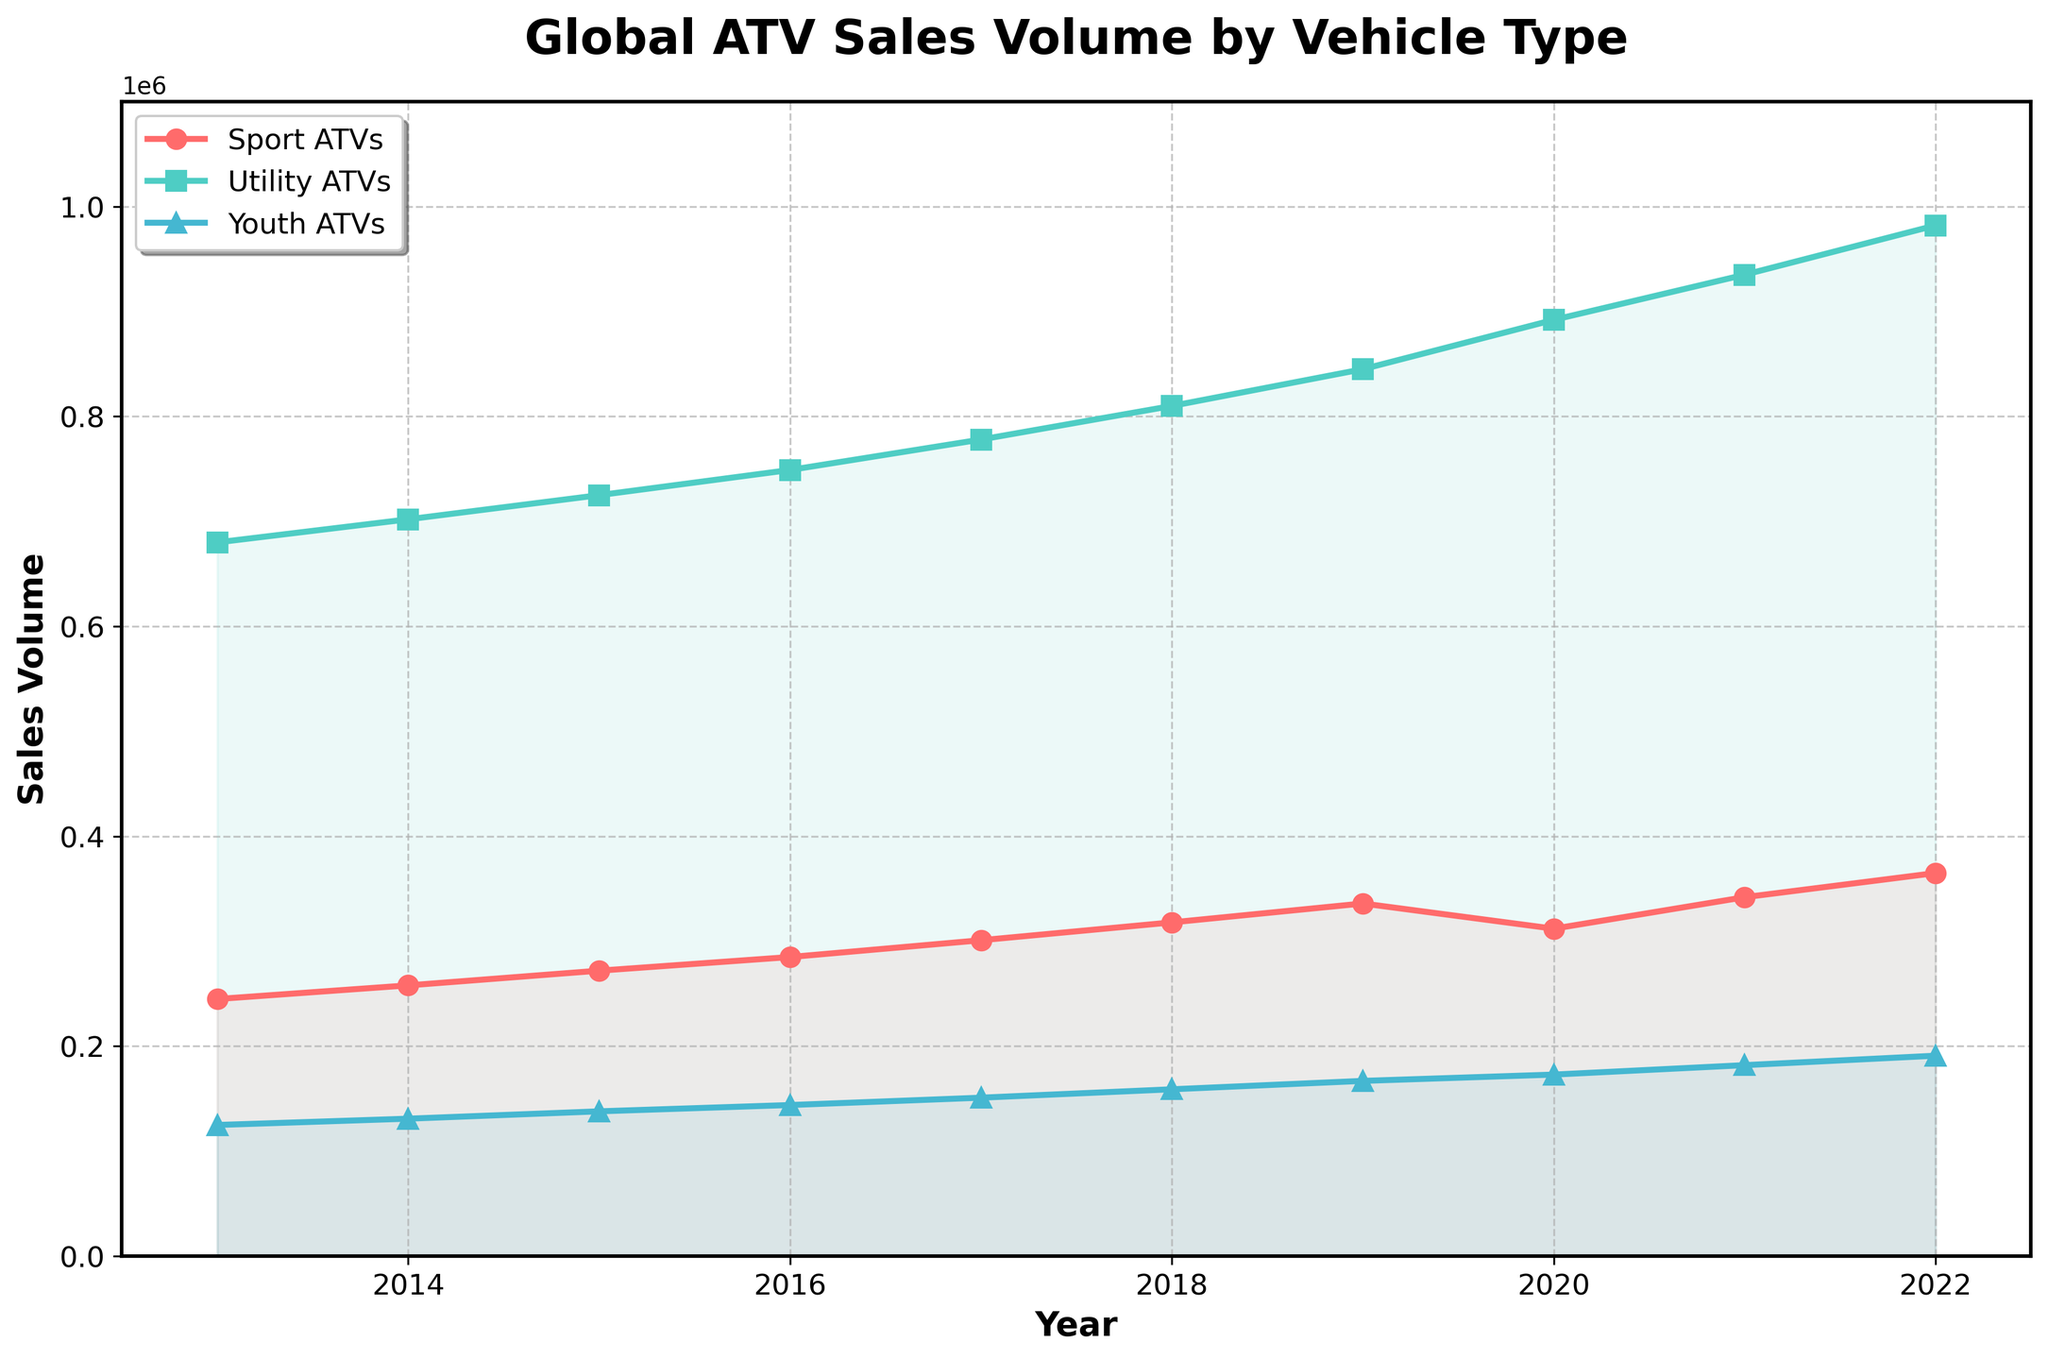What was the overall trend in Youth ATV sales from 2013 to 2022? From the plot, observe that the line representing Youth ATVs shows a consistent upward trend from 125,000 in 2013 to 191,000 in 2022. This trend indicates a steady increase in sales over the decade.
Answer: Steady increase Which year experienced a decline in Sport ATV sales? Locate the line for Sport ATVs and note that from 2019 to 2020, the number of sales dropped from 336,000 to 312,000.
Answer: 2020 What is the total sales volume for Utility ATVs in 2020 and 2021 combined? Identify the Utility ATVs sales volume for each of those years: 892,000 in 2020 and 935,000 in 2021. Add them together: 892,000 + 935,000 = 1,827,000.
Answer: 1,827,000 Compare the sales volume changes between Sport ATVs and Utility ATVs from 2021 to 2022. Which type had a greater increase? Sport ATVs increased from 342,000 to 365,000 (an increase of 23,000), and Utility ATVs increased from 935,000 to 982,000 (an increase of 47,000). Utility ATVs had a greater increase.
Answer: Utility ATVs What was the average sales volume for Sport ATVs over the last decade? Sum the Sport ATVs sales from 2013 to 2022 and divide by the number of years: (245,000 + 258,000 + 272,000 + 285,000 + 301,000 + 318,000 + 336,000 + 312,000 + 342,000 + 365,000) / 10 = 3,034,000 / 10.
Answer: 303,400 During which years did Utility ATVs consistently show an increasing trend? Observe the Utility ATVs line; from 2013 to 2022, the sales volume shows a consistent increase every year without any interruptions.
Answer: 2013-2022 In 2018, what was the difference in sales volumes between Utility ATVs and Sport ATVs? Locate the sales volumes for both types in 2018: Utility ATVs were 810,000, and Sport ATVs were 318,000. Calculate the difference: 810,000 - 318,000 = 492,000.
Answer: 492,000 What visual attributes distinguish Sport ATVs' sales trend line from the others? The Sport ATVs line is red, uses circular markers, and is positioned lower than Utility ATVs most of the time, highlighting its distinct visual characteristics.
Answer: Red, circular markers 